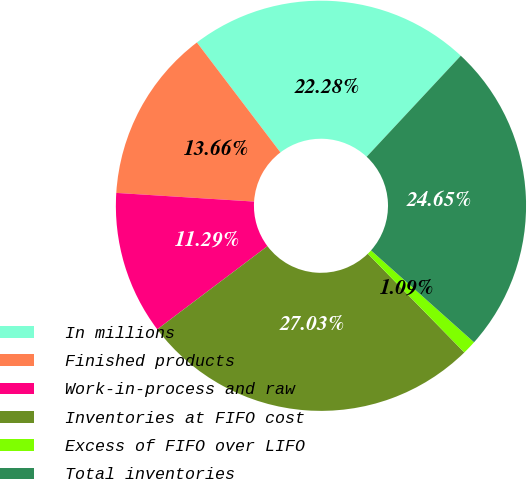<chart> <loc_0><loc_0><loc_500><loc_500><pie_chart><fcel>In millions<fcel>Finished products<fcel>Work-in-process and raw<fcel>Inventories at FIFO cost<fcel>Excess of FIFO over LIFO<fcel>Total inventories<nl><fcel>22.28%<fcel>13.66%<fcel>11.29%<fcel>27.03%<fcel>1.09%<fcel>24.65%<nl></chart> 